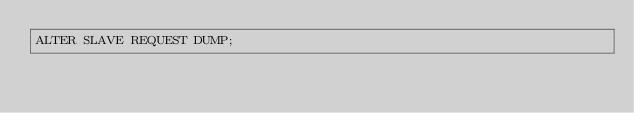Convert code to text. <code><loc_0><loc_0><loc_500><loc_500><_SQL_>ALTER SLAVE REQUEST DUMP;</code> 